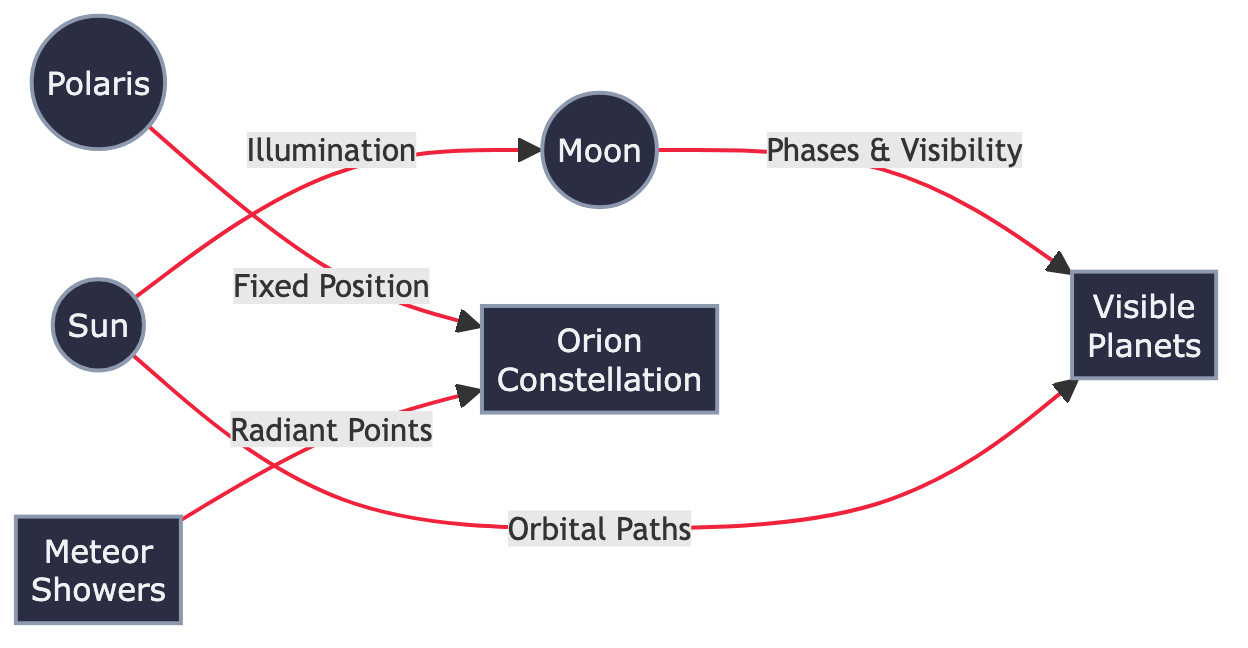What are the two celestial bodies directly related by the illumination connection? The diagram shows a direct connection labeled "Illumination" between the sun and the moon, indicating their relationship regarding light.
Answer: sun, moon How many celestial bodies are present in the diagram? The diagram illustrates a total of six celestial bodies: the sun, moon, polaris, orion, visible planets, and meteor showers. Counting these yields six.
Answer: 6 Which celestial body is fixed in position relative to the orion constellation? The diagram features a directed line indicating that polaris has a "Fixed Position" relative to orion, revealing their spatial relationship.
Answer: polaris What type of connection exists between the moon and the visible planets? The diagram specifies that the relationship between the moon and the visible planets is based on "Phases & Visibility," indicating how the moon influences the planets' appearance in the night sky.
Answer: Phases & Visibility How many edges are in the diagram? The diagram contains five connections (or edges) illustrated by the arrows connecting various celestial bodies, indicating their relationships.
Answer: 5 What is the radiant point of meteors as indicated in the diagram? The diagram shows that meteors point in the direction of orion, which serves as the radiant point for meteor showers, connecting them visually through a direct relationship.
Answer: orion What relationship connects the sun to the visible planets? The diagram defines the connection between the sun and the visible planets as "Orbital Paths," meaning the paths of the planets are influenced by the sun's gravitational pull.
Answer: Orbital Paths How many different types of celestial phenomena are shown in the diagram? The diagram includes celestial phenomena such as illumination (sun and moon), fixed position (polaris and orion), phases and visibility (moon and planets), and meteor showers related to radiant points (to orion), making a total of four types.
Answer: 4 What is the main celestial body at the top of the diagram? The most prominent celestial body depicted at the top of the diagram is the sun, which also serves as the source of illumination for the moon.
Answer: sun 